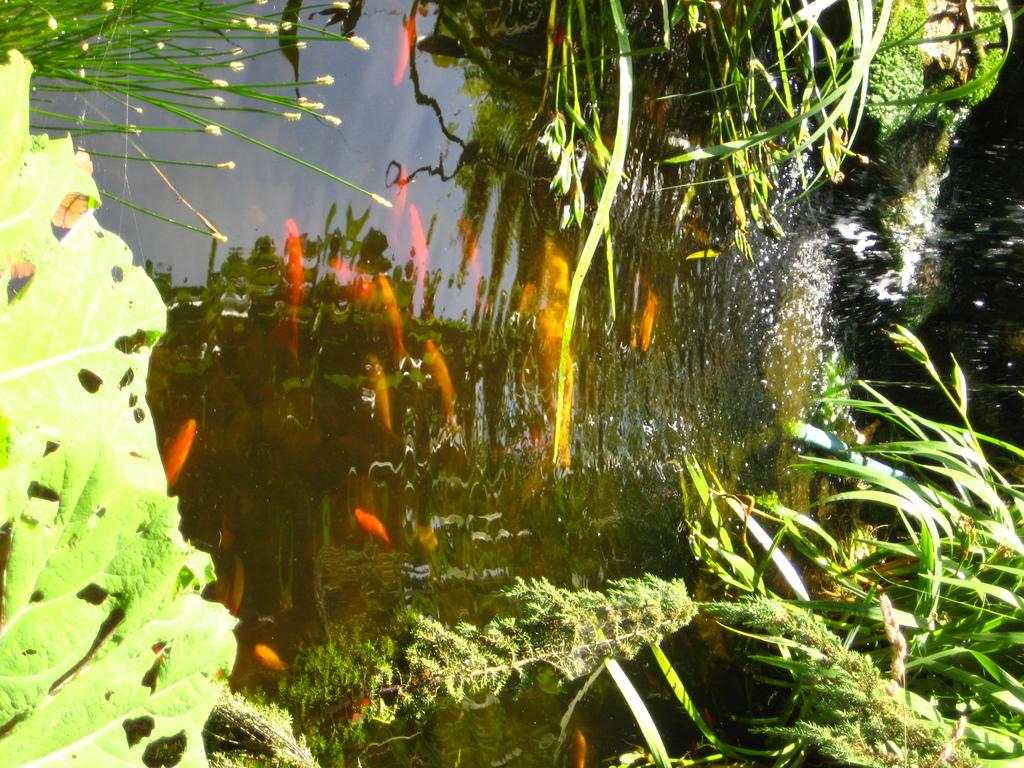What type of vegetation is visible in the image? There is grass in the image. What can be seen in the water in the image? There are fish in the water in the image. What type of railway is present in the image? There is no railway present in the image; it features grass and fish in the water. What is the quiver used for in the image? There is no quiver present in the image. 